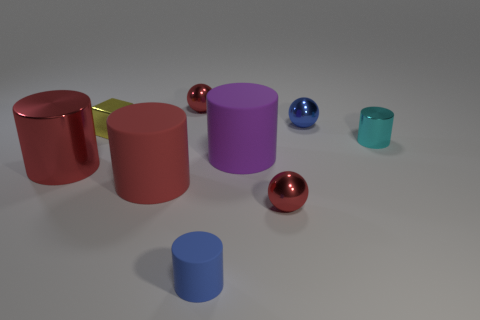Which object stands out the most and why? The red sphere stands out due to its vibrant color that contrasts sharply with the more subdued tones of the surrounding objects and the neutral background, naturally drawing the viewer's eye. 